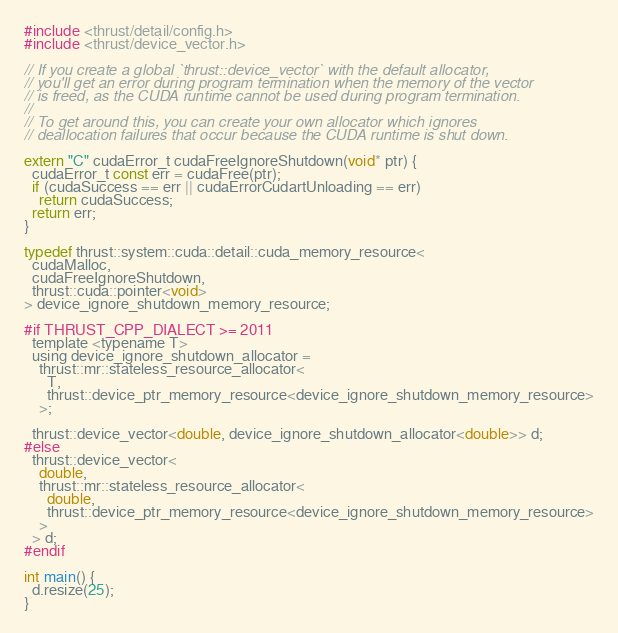<code> <loc_0><loc_0><loc_500><loc_500><_Cuda_>#include <thrust/detail/config.h>
#include <thrust/device_vector.h>

// If you create a global `thrust::device_vector` with the default allocator,
// you'll get an error during program termination when the memory of the vector
// is freed, as the CUDA runtime cannot be used during program termination.
//
// To get around this, you can create your own allocator which ignores
// deallocation failures that occur because the CUDA runtime is shut down.

extern "C" cudaError_t cudaFreeIgnoreShutdown(void* ptr) {
  cudaError_t const err = cudaFree(ptr);
  if (cudaSuccess == err || cudaErrorCudartUnloading == err)
    return cudaSuccess;
  return err; 
}

typedef thrust::system::cuda::detail::cuda_memory_resource<
  cudaMalloc, 
  cudaFreeIgnoreShutdown,
  thrust::cuda::pointer<void>
> device_ignore_shutdown_memory_resource;

#if THRUST_CPP_DIALECT >= 2011
  template <typename T>
  using device_ignore_shutdown_allocator = 
    thrust::mr::stateless_resource_allocator<
      T,
      thrust::device_ptr_memory_resource<device_ignore_shutdown_memory_resource>
    >;
    
  thrust::device_vector<double, device_ignore_shutdown_allocator<double>> d;
#else
  thrust::device_vector<
    double, 
    thrust::mr::stateless_resource_allocator<
      double,
      thrust::device_ptr_memory_resource<device_ignore_shutdown_memory_resource>
    > 
  > d;
#endif

int main() {
  d.resize(25);
}

</code> 